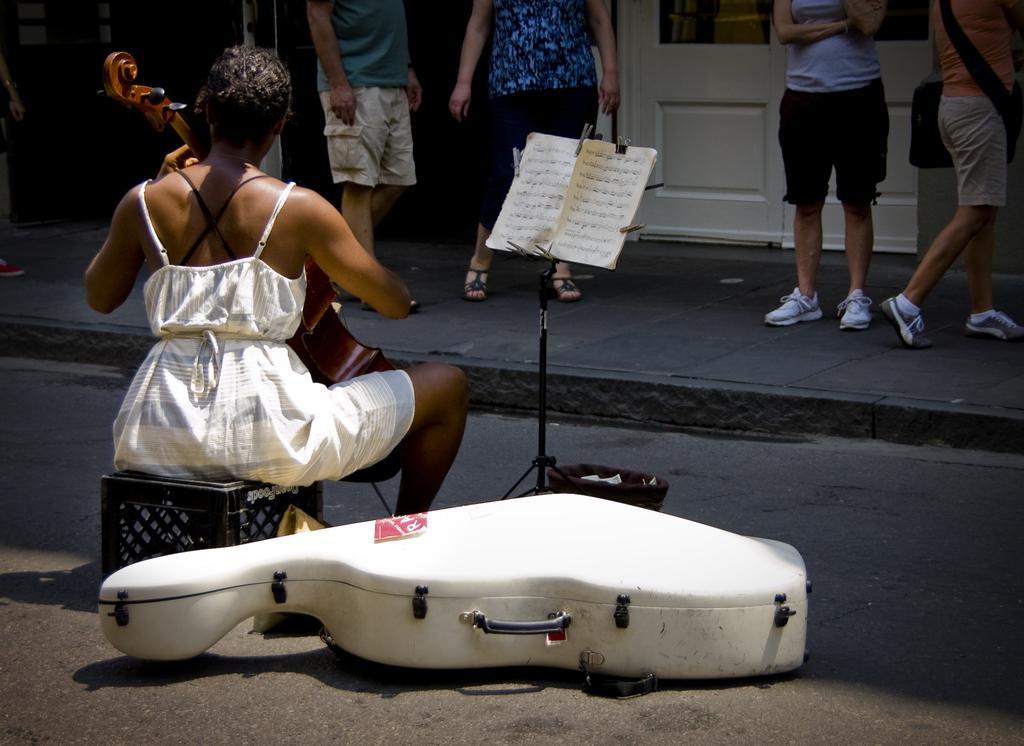Describe this image in one or two sentences. In this image, there are a few people. Among them, we can see a person holding a musical instrument. We can see the ground with some objects. We can see a stool. We can see a stand with some papers. We can also see a white colored door and a pole. 